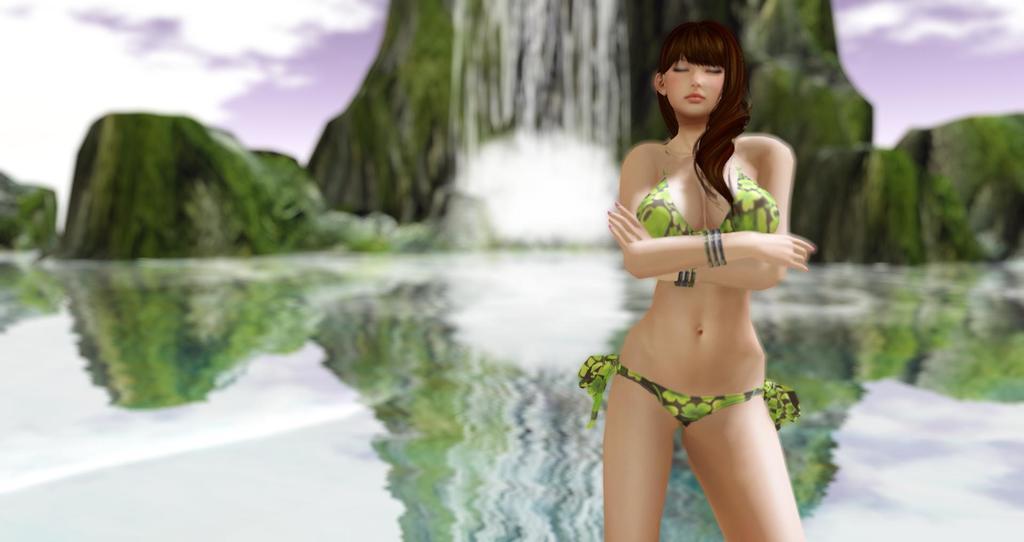Please provide a concise description of this image. This is an animation picture. On this there is a lady standing. In the back it is looking blurred and there is water, sky, and hills with waterfall. 